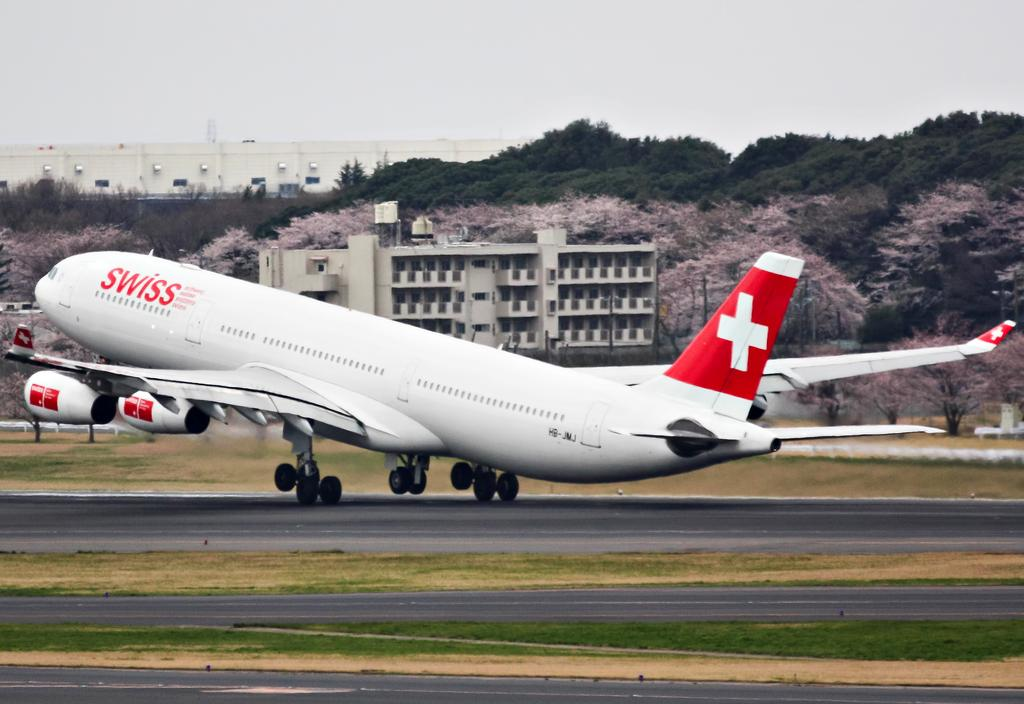What is the main subject of the picture? The main subject of the picture is an airplane. What can be seen at the bottom of the picture? There is grass at the bottom of the picture. What is visible in the background of the picture? There are trees and a building in the background of the picture. What is visible at the top of the picture? The sky is visible at the top of the picture. What type of juice is being served on the airplane in the image? There is no indication of any juice or beverage service in the image; it only shows an airplane. Can you see any dirt on the airplane in the image? There is no dirt visible on the airplane in the image. 